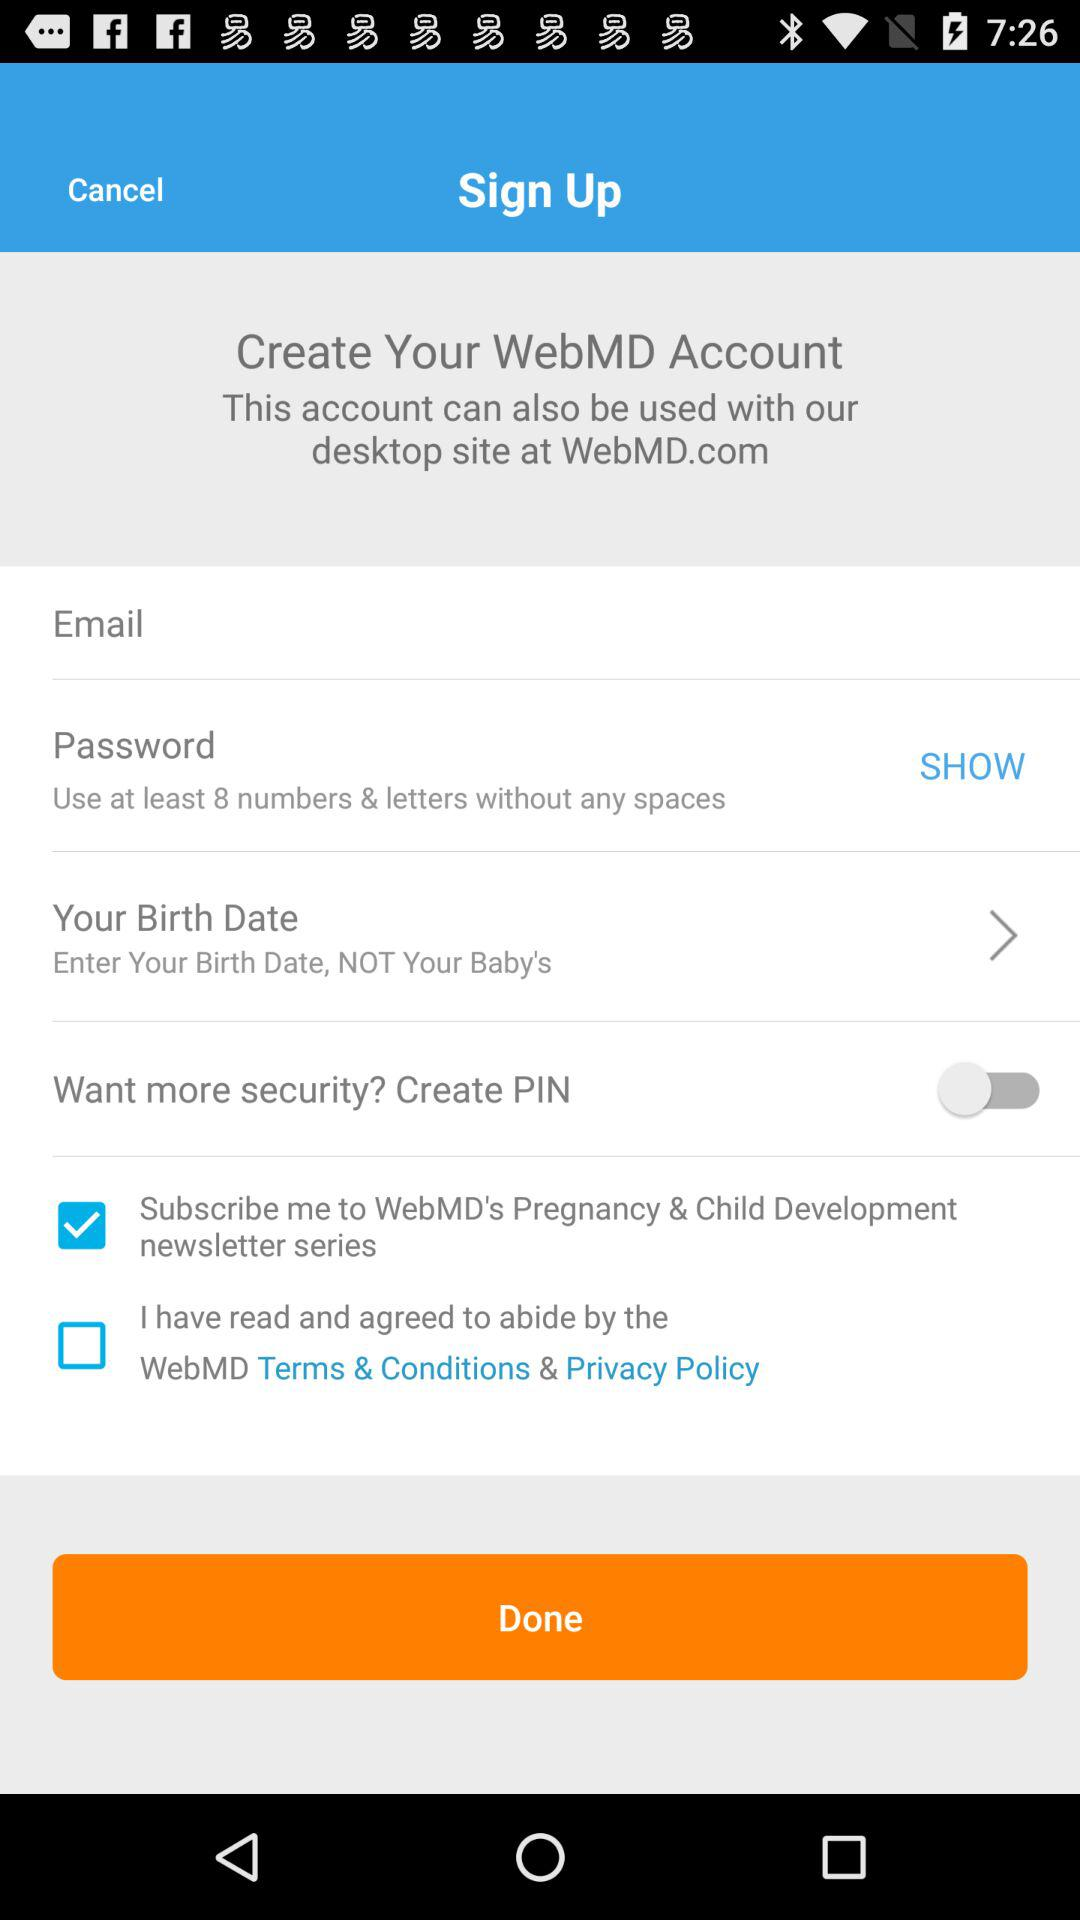What option is marked as checked? The option marked as checked is "Subscribe me to WebMD's Pregnancy & Child Development newsletter series". 